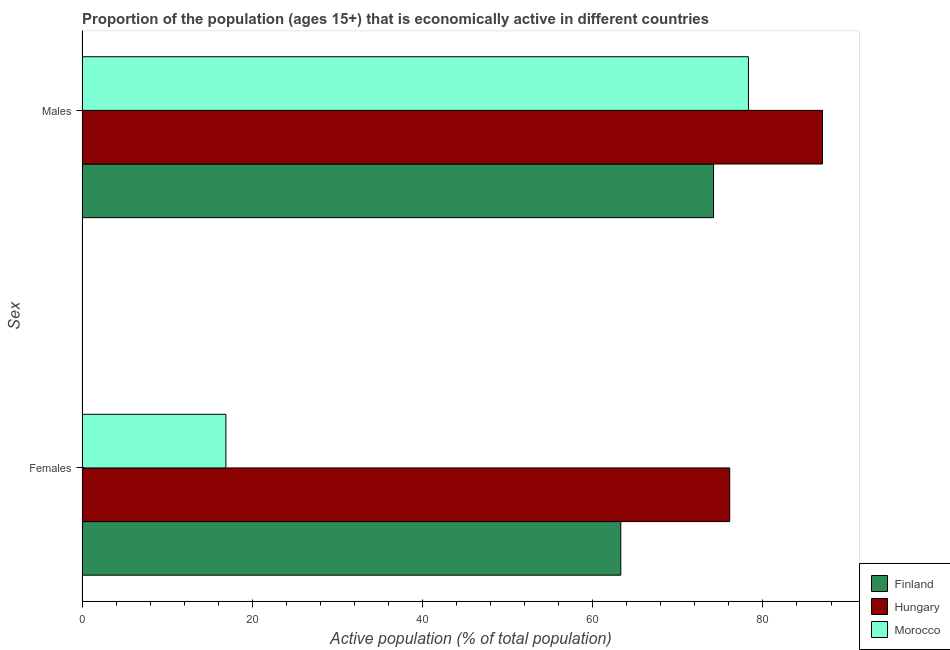Are the number of bars per tick equal to the number of legend labels?
Offer a very short reply. Yes. How many bars are there on the 1st tick from the top?
Provide a succinct answer. 3. How many bars are there on the 1st tick from the bottom?
Give a very brief answer. 3. What is the label of the 1st group of bars from the top?
Provide a short and direct response. Males. What is the percentage of economically active female population in Hungary?
Your answer should be very brief. 76.1. Across all countries, what is the maximum percentage of economically active female population?
Your response must be concise. 76.1. Across all countries, what is the minimum percentage of economically active male population?
Give a very brief answer. 74.2. In which country was the percentage of economically active male population maximum?
Give a very brief answer. Hungary. What is the total percentage of economically active female population in the graph?
Offer a very short reply. 156.3. What is the difference between the percentage of economically active male population in Finland and that in Hungary?
Give a very brief answer. -12.8. What is the difference between the percentage of economically active male population in Morocco and the percentage of economically active female population in Finland?
Provide a succinct answer. 15. What is the average percentage of economically active female population per country?
Make the answer very short. 52.1. What is the difference between the percentage of economically active female population and percentage of economically active male population in Hungary?
Your answer should be very brief. -10.9. What is the ratio of the percentage of economically active male population in Morocco to that in Hungary?
Offer a terse response. 0.9. Is the percentage of economically active male population in Finland less than that in Hungary?
Your response must be concise. Yes. In how many countries, is the percentage of economically active male population greater than the average percentage of economically active male population taken over all countries?
Make the answer very short. 1. What does the 1st bar from the top in Males represents?
Provide a short and direct response. Morocco. What does the 1st bar from the bottom in Males represents?
Make the answer very short. Finland. Are the values on the major ticks of X-axis written in scientific E-notation?
Your answer should be compact. No. Does the graph contain grids?
Keep it short and to the point. No. How many legend labels are there?
Keep it short and to the point. 3. How are the legend labels stacked?
Ensure brevity in your answer.  Vertical. What is the title of the graph?
Your answer should be compact. Proportion of the population (ages 15+) that is economically active in different countries. What is the label or title of the X-axis?
Provide a succinct answer. Active population (% of total population). What is the label or title of the Y-axis?
Your answer should be compact. Sex. What is the Active population (% of total population) of Finland in Females?
Offer a very short reply. 63.3. What is the Active population (% of total population) of Hungary in Females?
Provide a succinct answer. 76.1. What is the Active population (% of total population) of Morocco in Females?
Your answer should be very brief. 16.9. What is the Active population (% of total population) of Finland in Males?
Keep it short and to the point. 74.2. What is the Active population (% of total population) in Hungary in Males?
Provide a short and direct response. 87. What is the Active population (% of total population) in Morocco in Males?
Give a very brief answer. 78.3. Across all Sex, what is the maximum Active population (% of total population) of Finland?
Offer a very short reply. 74.2. Across all Sex, what is the maximum Active population (% of total population) of Hungary?
Give a very brief answer. 87. Across all Sex, what is the maximum Active population (% of total population) in Morocco?
Your answer should be compact. 78.3. Across all Sex, what is the minimum Active population (% of total population) in Finland?
Make the answer very short. 63.3. Across all Sex, what is the minimum Active population (% of total population) in Hungary?
Give a very brief answer. 76.1. Across all Sex, what is the minimum Active population (% of total population) in Morocco?
Provide a succinct answer. 16.9. What is the total Active population (% of total population) of Finland in the graph?
Keep it short and to the point. 137.5. What is the total Active population (% of total population) of Hungary in the graph?
Give a very brief answer. 163.1. What is the total Active population (% of total population) of Morocco in the graph?
Your answer should be compact. 95.2. What is the difference between the Active population (% of total population) of Finland in Females and that in Males?
Ensure brevity in your answer.  -10.9. What is the difference between the Active population (% of total population) of Hungary in Females and that in Males?
Ensure brevity in your answer.  -10.9. What is the difference between the Active population (% of total population) of Morocco in Females and that in Males?
Make the answer very short. -61.4. What is the difference between the Active population (% of total population) in Finland in Females and the Active population (% of total population) in Hungary in Males?
Provide a short and direct response. -23.7. What is the difference between the Active population (% of total population) of Hungary in Females and the Active population (% of total population) of Morocco in Males?
Offer a terse response. -2.2. What is the average Active population (% of total population) in Finland per Sex?
Make the answer very short. 68.75. What is the average Active population (% of total population) in Hungary per Sex?
Offer a very short reply. 81.55. What is the average Active population (% of total population) of Morocco per Sex?
Keep it short and to the point. 47.6. What is the difference between the Active population (% of total population) in Finland and Active population (% of total population) in Hungary in Females?
Offer a very short reply. -12.8. What is the difference between the Active population (% of total population) in Finland and Active population (% of total population) in Morocco in Females?
Keep it short and to the point. 46.4. What is the difference between the Active population (% of total population) of Hungary and Active population (% of total population) of Morocco in Females?
Ensure brevity in your answer.  59.2. What is the difference between the Active population (% of total population) of Hungary and Active population (% of total population) of Morocco in Males?
Your response must be concise. 8.7. What is the ratio of the Active population (% of total population) in Finland in Females to that in Males?
Make the answer very short. 0.85. What is the ratio of the Active population (% of total population) of Hungary in Females to that in Males?
Your response must be concise. 0.87. What is the ratio of the Active population (% of total population) in Morocco in Females to that in Males?
Your answer should be compact. 0.22. What is the difference between the highest and the second highest Active population (% of total population) of Morocco?
Provide a short and direct response. 61.4. What is the difference between the highest and the lowest Active population (% of total population) of Morocco?
Your answer should be very brief. 61.4. 